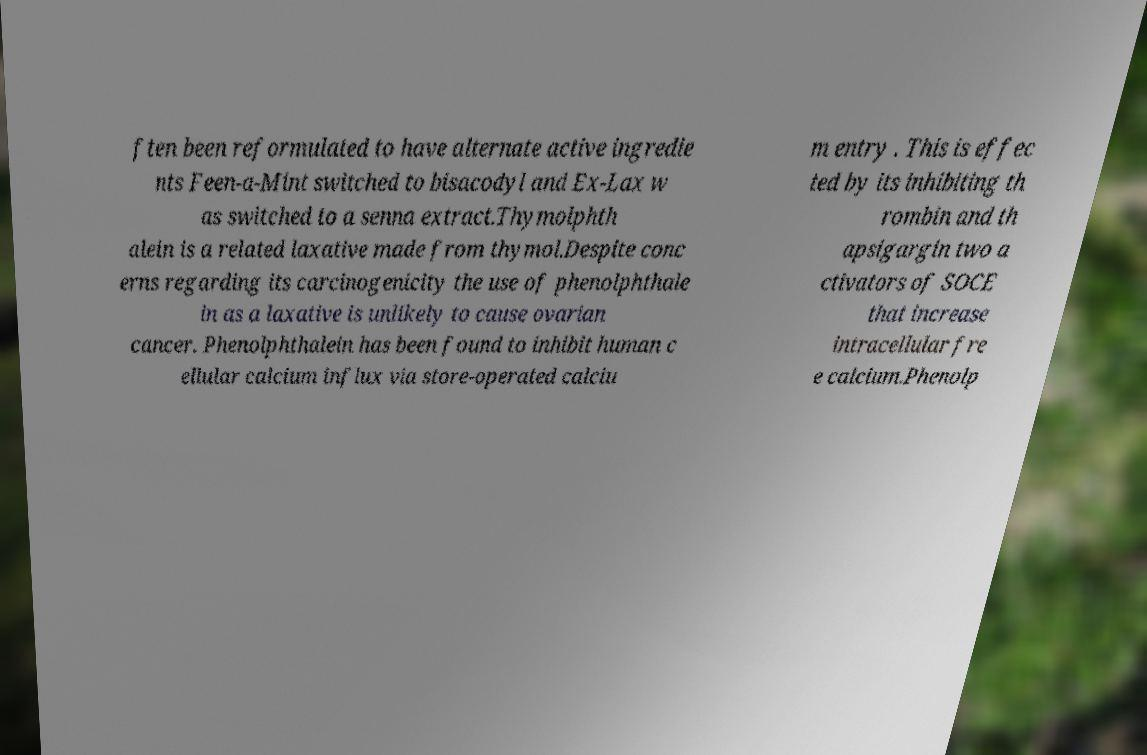Could you extract and type out the text from this image? ften been reformulated to have alternate active ingredie nts Feen-a-Mint switched to bisacodyl and Ex-Lax w as switched to a senna extract.Thymolphth alein is a related laxative made from thymol.Despite conc erns regarding its carcinogenicity the use of phenolphthale in as a laxative is unlikely to cause ovarian cancer. Phenolphthalein has been found to inhibit human c ellular calcium influx via store-operated calciu m entry . This is effec ted by its inhibiting th rombin and th apsigargin two a ctivators of SOCE that increase intracellular fre e calcium.Phenolp 